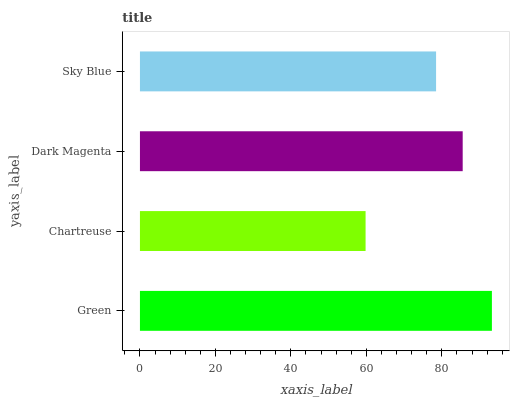Is Chartreuse the minimum?
Answer yes or no. Yes. Is Green the maximum?
Answer yes or no. Yes. Is Dark Magenta the minimum?
Answer yes or no. No. Is Dark Magenta the maximum?
Answer yes or no. No. Is Dark Magenta greater than Chartreuse?
Answer yes or no. Yes. Is Chartreuse less than Dark Magenta?
Answer yes or no. Yes. Is Chartreuse greater than Dark Magenta?
Answer yes or no. No. Is Dark Magenta less than Chartreuse?
Answer yes or no. No. Is Dark Magenta the high median?
Answer yes or no. Yes. Is Sky Blue the low median?
Answer yes or no. Yes. Is Green the high median?
Answer yes or no. No. Is Dark Magenta the low median?
Answer yes or no. No. 